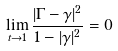Convert formula to latex. <formula><loc_0><loc_0><loc_500><loc_500>\lim _ { t \to 1 } \frac { | \Gamma - \gamma | ^ { 2 } } { 1 - | \gamma | ^ { 2 } } = 0</formula> 